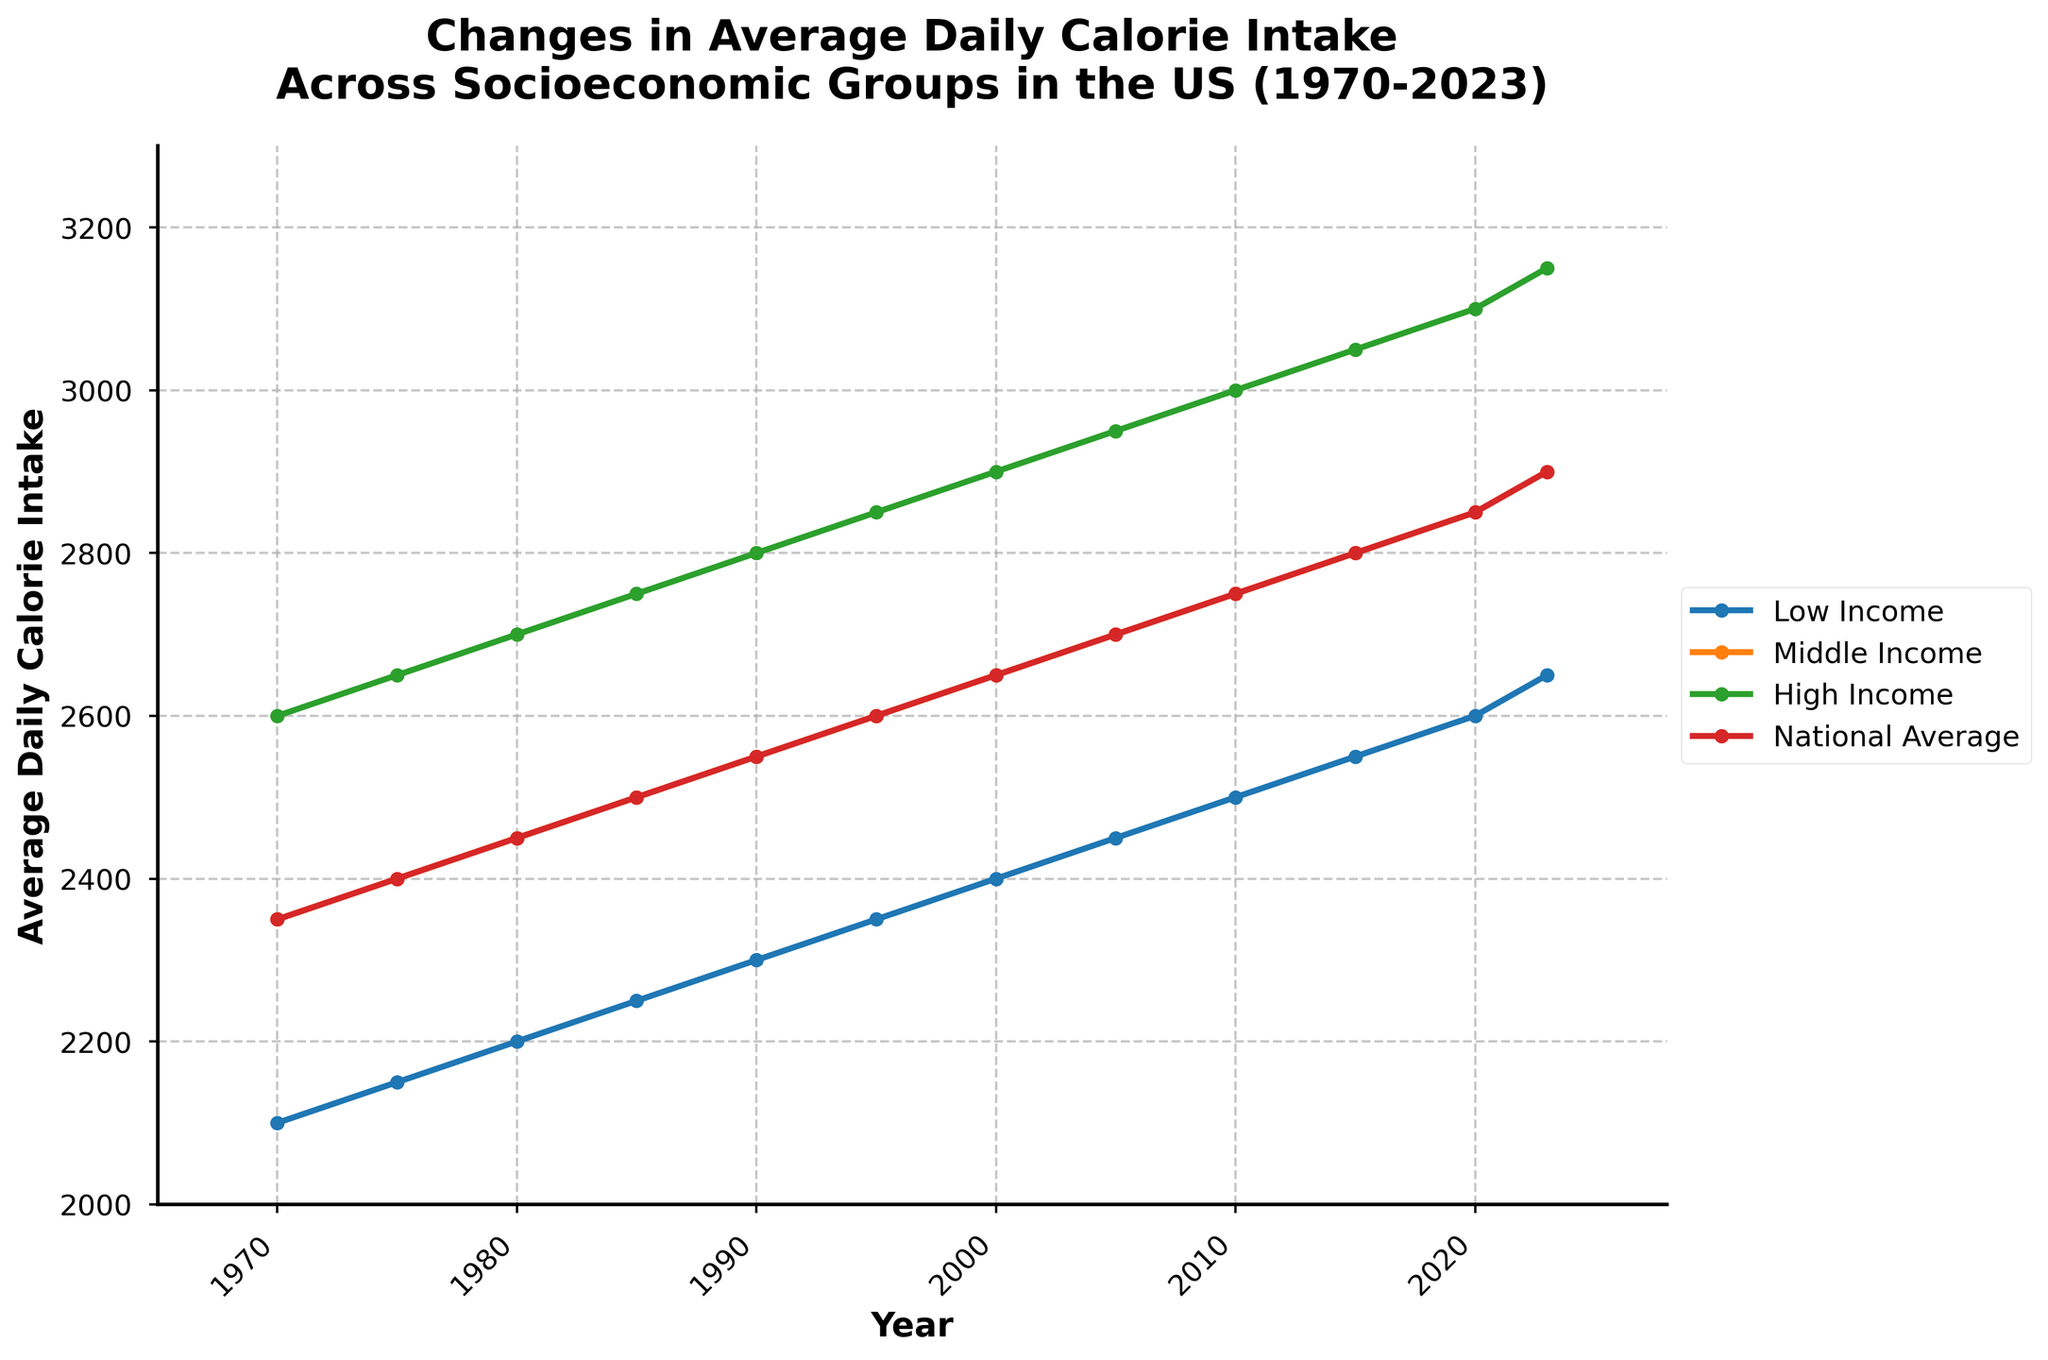What is the trend in average daily calorie intake for the Low Income group from 1970 to 2023? The average daily calorie intake for the Low Income group shows a consistent increase from 2100 in 1970 to 2650 in 2023.
Answer: Increasing Which socioeconomic group had the highest average daily calorie intake in 1990? In 1990, the High Income group had the highest average daily calorie intake at 2800.
Answer: High Income By how much did the National Average daily calorie intake increase from 1970 to 2023? The National Average daily calorie intake increased from 2350 in 1970 to 2900 in 2023. The increase is 2900 - 2350 = 550 calories.
Answer: 550 calories In which year did the Middle Income group surpass 2600 calories in their average daily intake? The Middle Income group surpassed 2600 calories in their average daily intake in the year 1995.
Answer: 1995 Compare the average daily calorie intake of the Middle Income and High Income groups in 2005. In 2005, the average daily calorie intake for the Middle Income group was 2700, while for the High Income group it was 2950. The High Income group had a 250-calorie higher intake than the Middle Income group.
Answer: High Income What is the difference in average daily calorie intake between the Low Income and High Income groups in 2023? In 2023, the Low Income group had an average daily calorie intake of 2650, while the High Income group had 3150. The difference is 3150 - 2650 = 500 calories.
Answer: 500 calories How does the change in average daily calorie intake for the National Average from 2000 to 2023 compare to that of the Middle Income group in the same period? From 2000 to 2023, the National Average increased from 2650 to 2900, a change of 250 calories. The Middle Income group increased from 2650 to 2900, which is also a change of 250 calories.
Answer: The same Which group had the closest average daily calorie intake to the National Average in 2010? In 2010, the Middle Income group had an average daily calorie intake of 2750, which is exactly the same as the National Average.
Answer: Middle Income Is there any year where the National Average daily calorie intake stayed the same as the previous year? Yes, between the years 1970 and 1975, the National Average daily calorie intake stayed the same at 2350.
Answer: Yes What is the visual pattern observed in the lines representing the calorie intake of all groups over the years? The visual pattern shows that all lines representing the calorie intake of the different groups exhibit a steady upward trend over the years from 1970 to 2023, with the High Income group consistently having the highest intake and the Low Income group the lowest.
Answer: Upward trend 